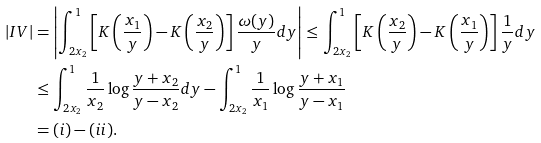<formula> <loc_0><loc_0><loc_500><loc_500>| I V | & = \left | \int _ { 2 x _ { 2 } } ^ { 1 } \left [ K \left ( \frac { x _ { 1 } } { y } \right ) - K \left ( \frac { x _ { 2 } } { y } \right ) \right ] \frac { \omega ( y ) } { y } d y \right | \leq \int _ { 2 x _ { 2 } } ^ { 1 } \left [ K \left ( \frac { x _ { 2 } } { y } \right ) - K \left ( \frac { x _ { 1 } } { y } \right ) \right ] \frac { 1 } { y } d y \\ & \leq \int _ { 2 x _ { 2 } } ^ { 1 } \frac { 1 } { x _ { 2 } } \log \frac { y + x _ { 2 } } { y - x _ { 2 } } d y - \int _ { 2 x _ { 2 } } ^ { 1 } \frac { 1 } { x _ { 1 } } \log \frac { y + x _ { 1 } } { y - x _ { 1 } } \\ & = ( i ) - ( i i ) .</formula> 